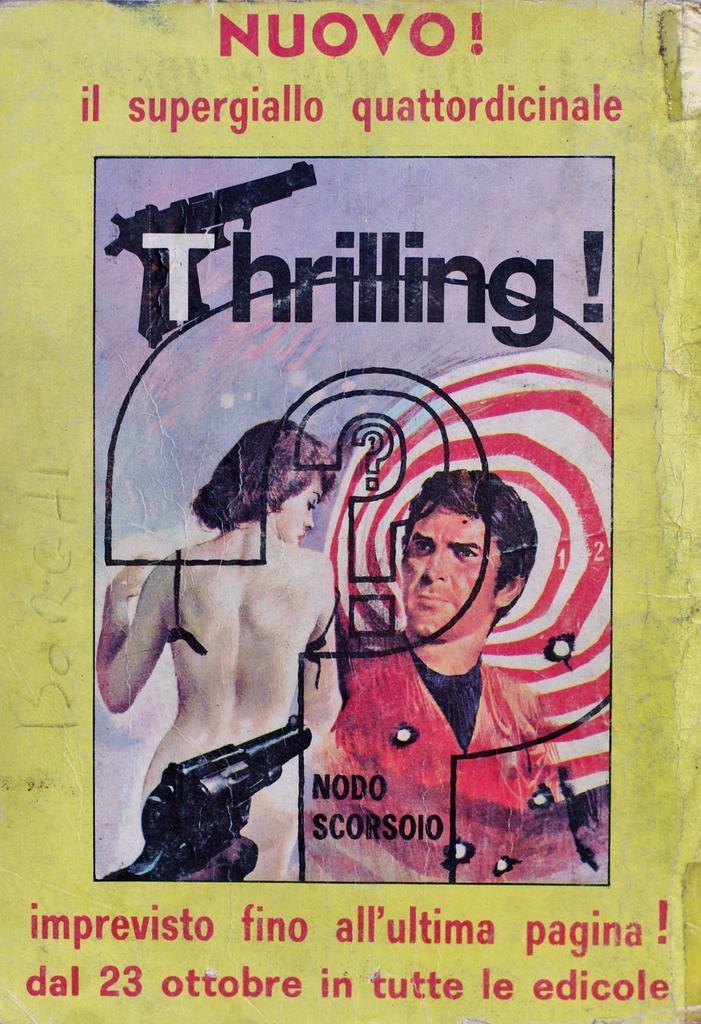Please provide a concise description of this image. In this picture we can see a poster, in the poster we can find some text and few people. 